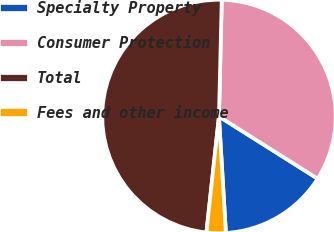Convert chart to OTSL. <chart><loc_0><loc_0><loc_500><loc_500><pie_chart><fcel>Specialty Property<fcel>Consumer Protection<fcel>Total<fcel>Fees and other income<nl><fcel>15.1%<fcel>33.57%<fcel>48.67%<fcel>2.66%<nl></chart> 